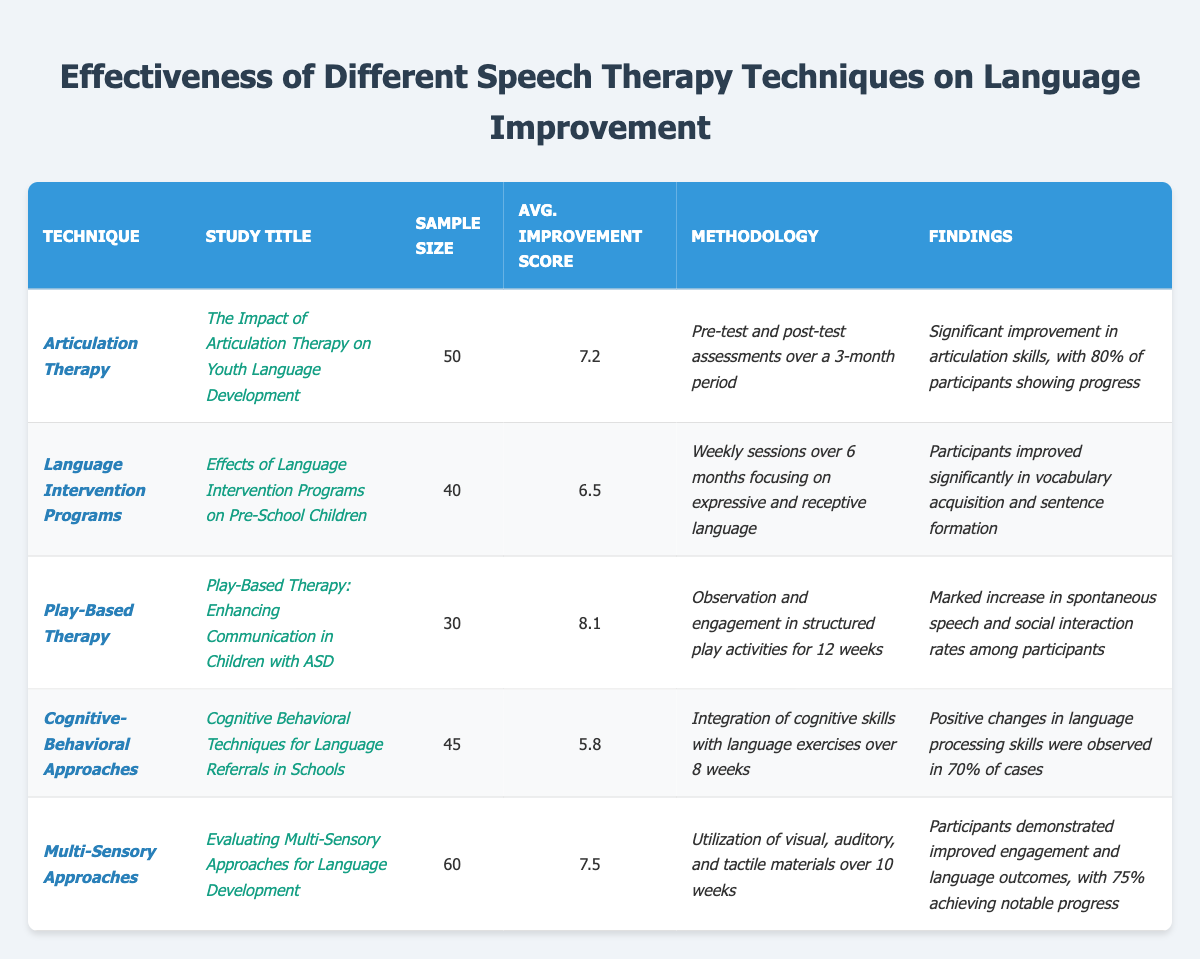What is the average improvement score for Play-Based Therapy? The average improvement score for Play-Based Therapy is listed in the table as 8.1.
Answer: 8.1 Which technique had the highest average improvement score? By comparing the average improvement scores, Play-Based Therapy at 8.1 has the highest score among all techniques listed.
Answer: Play-Based Therapy How many participants were involved in the Language Intervention Programs study? The sample size for the Language Intervention Programs study is 40 participants as shown in the table.
Answer: 40 Was the average improvement score for Cognitive-Behavioral Approaches above or below 6.0? The average improvement score for Cognitive-Behavioral Approaches is 5.8, which is below 6.0.
Answer: Below What is the difference in average improvement scores between Multi-Sensory Approaches and Cognitive-Behavioral Approaches? Multi-Sensory Approaches have an average score of 7.5, while Cognitive-Behavioral Approaches have an average score of 5.8. The difference is 7.5 - 5.8 = 1.7.
Answer: 1.7 Did the Articulation Therapy study show that 80% of participants improved? Yes, the findings for the Articulation Therapy study indicate that 80% of participants showed improvement.
Answer: Yes If you combine the sample sizes of Language Intervention Programs and Play-Based Therapy, what total sample size do you get? The sample size for Language Intervention Programs is 40, and for Play-Based Therapy, it is 30. Adding them gives 40 + 30 = 70.
Answer: 70 Which techniques utilized a pre-test and post-test methodology? The only technique listed with a pre-test and post-test methodology is Articulation Therapy as stated in its methodology.
Answer: Articulation Therapy What percentage of participants in Cognitive-Behavioral Approaches showed positive changes? It is mentioned that 70% of cases observed positive changes in language processing skills in Cognitive-Behavioral Approaches.
Answer: 70% Which technique involved the largest sample size and what was that size? Multi-Sensory Approaches had the largest sample size of 60 participants as noted in the table.
Answer: 60 